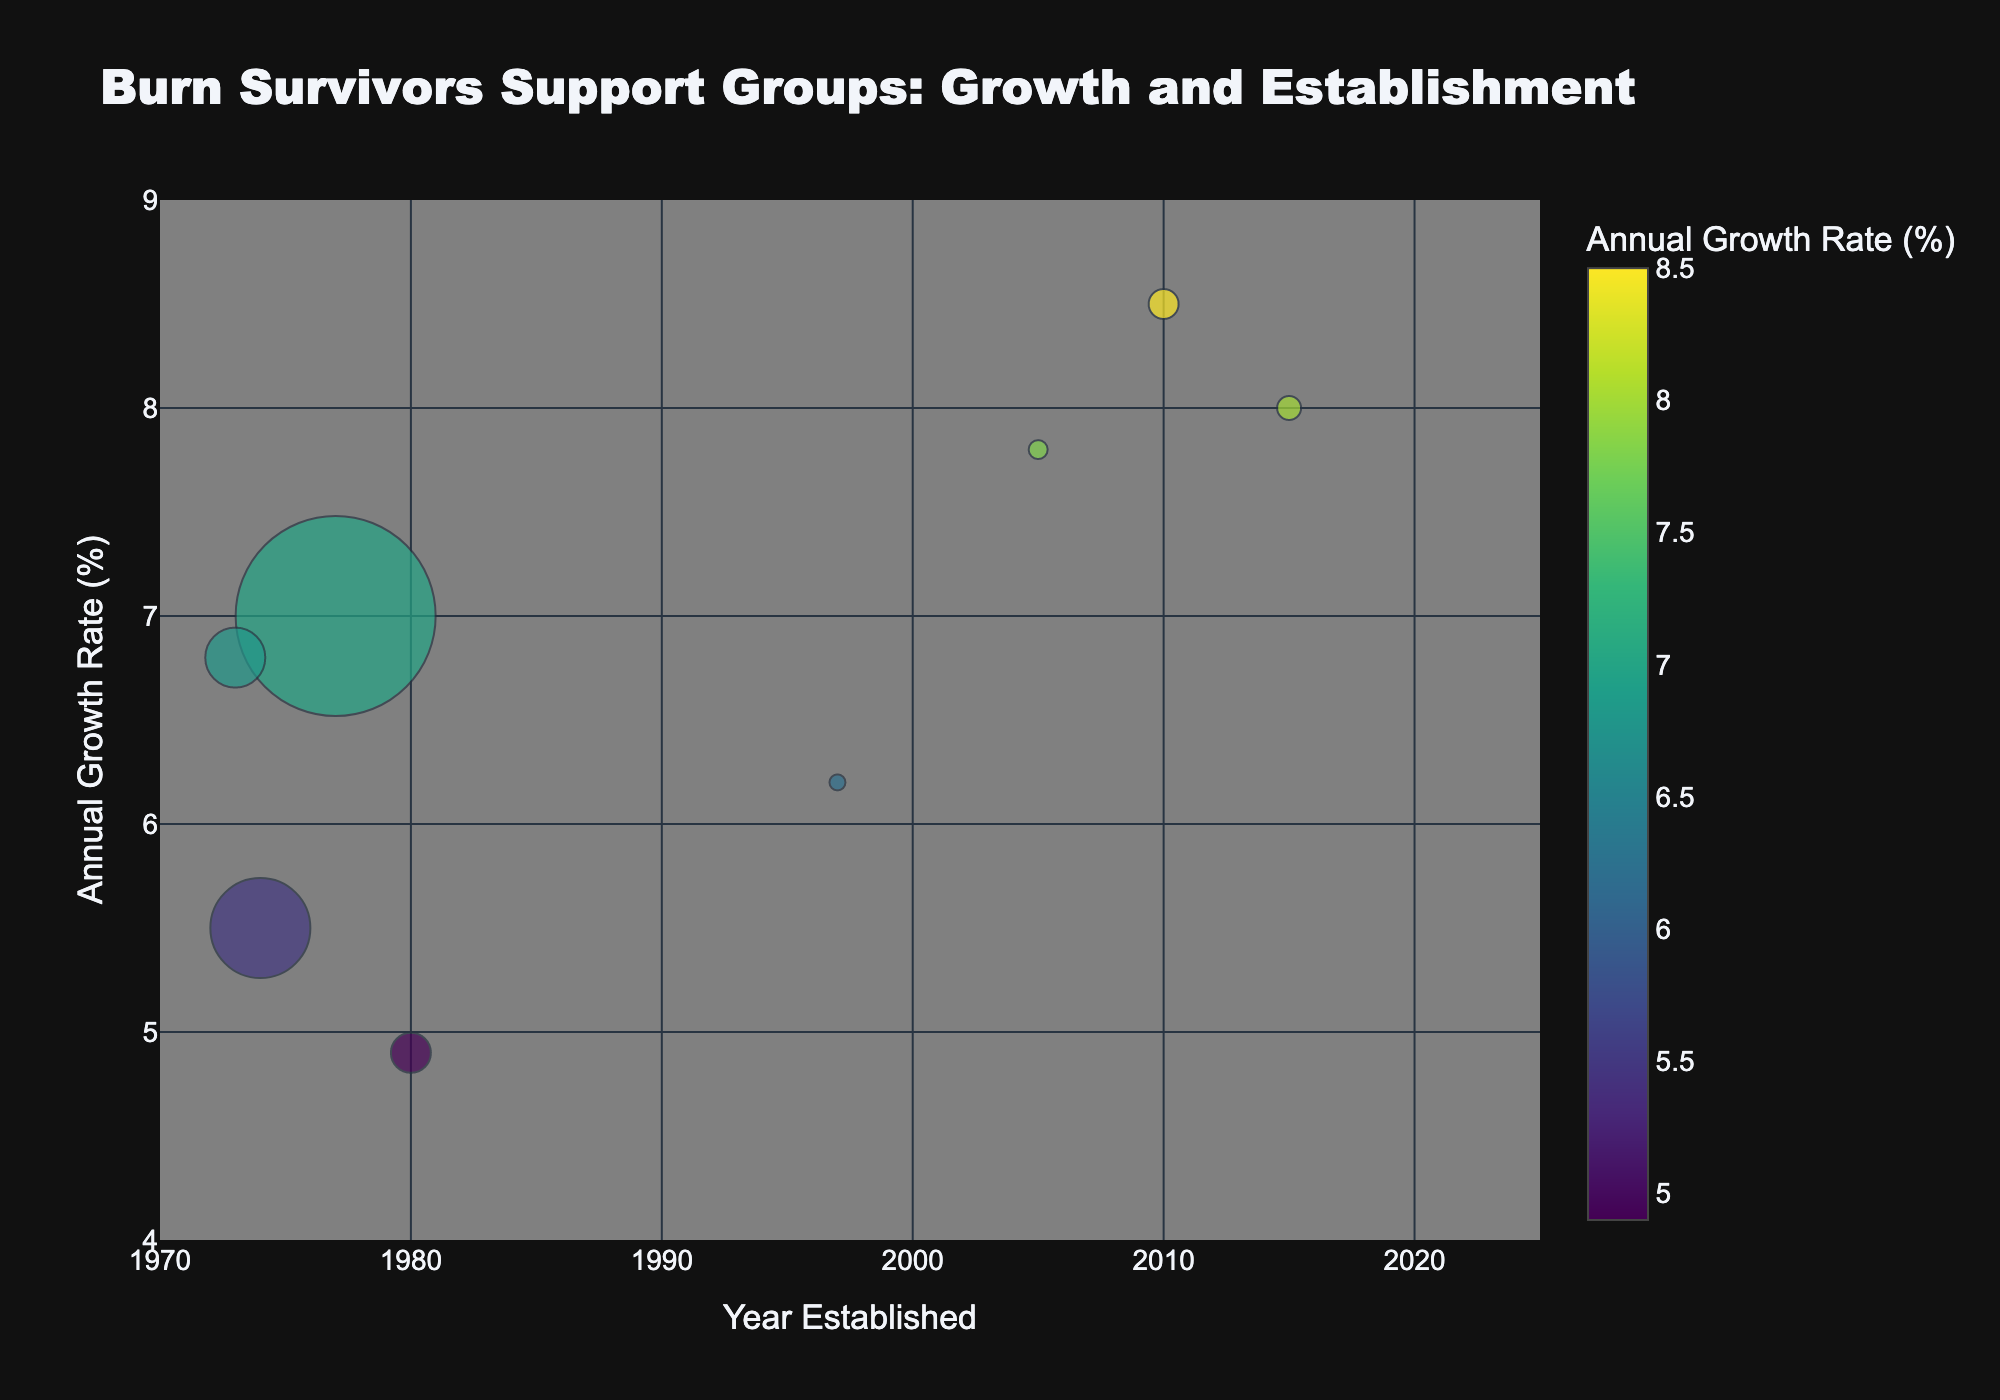How many support groups are displayed in the figure? Count the number of bubbles in the chart.
Answer: 8 Which support group shows the highest annual growth rate? Identify the bubble with the highest y-coordinate on the value axis labeled 'Annual Growth Rate (%)'.
Answer: Burn Survivors Support Network What is the average annual growth rate of all the groups presented? Sum the annual growth rate percentages of all groups (8.5 + 7.0 + 5.5 + 6.2 + 6.8 + 7.8 + 4.9 + 8.0) and then divide by the number of groups (8).
Answer: 6.85% Which year had the most support groups established? Identify the year on the x-axis that has the most bubbles aligned vertically.
Answer: None, each year different Which group has the largest number of members, and what is their annual growth rate? Look for the bubble with the largest size and note the group name along with the corresponding y-coordinate.
Answer: Phoenix Society for Burn Survivors, 7.0% What is the difference in annual growth rates between the Burn Survivors Support Network and the Hospital Burn Support Centers? Subtract the annual growth rate of Hospital Burn Support Centers (4.9%) from that of the Burn Survivors Support Network (8.5%).
Answer: 3.6% Which group established after the year 2000 has the highest growth rate? Identify the bubbles plotted on the right side of the x-axis after 2000 and find the one with the highest y-coordinate.
Answer: Burn Survivors Support Network Compare the number of members of the Firefighters Burn Institute and Burn Recovery Support. Which has more? Identify the sizes of the bubbles corresponding to these groups and compare.
Answer: Firefighters Burn Institute What trend can you identify between the year established and the annual growth rate? Assess whether older or more recently established support groups have higher growth rates by visually examining the scatter plot trend.
Answer: No clear trend What is the significance of the color scale in the bubble chart? Explain what the color of each bubble represents based on the color bar.
Answer: Annual Growth Rate (%) 